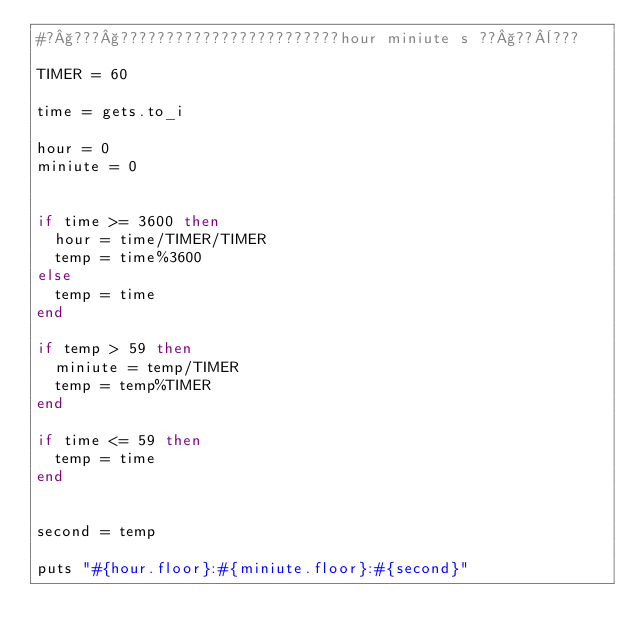<code> <loc_0><loc_0><loc_500><loc_500><_Ruby_>#?§???§????????????????????????hour miniute s ??§??¨???

TIMER = 60

time = gets.to_i

hour = 0
miniute = 0


if time >= 3600 then
	hour = time/TIMER/TIMER
	temp = time%3600
else 
	temp = time
end

if temp > 59 then
	miniute = temp/TIMER
	temp = temp%TIMER
end

if time <= 59 then
	temp = time
end


second = temp

puts "#{hour.floor}:#{miniute.floor}:#{second}"</code> 